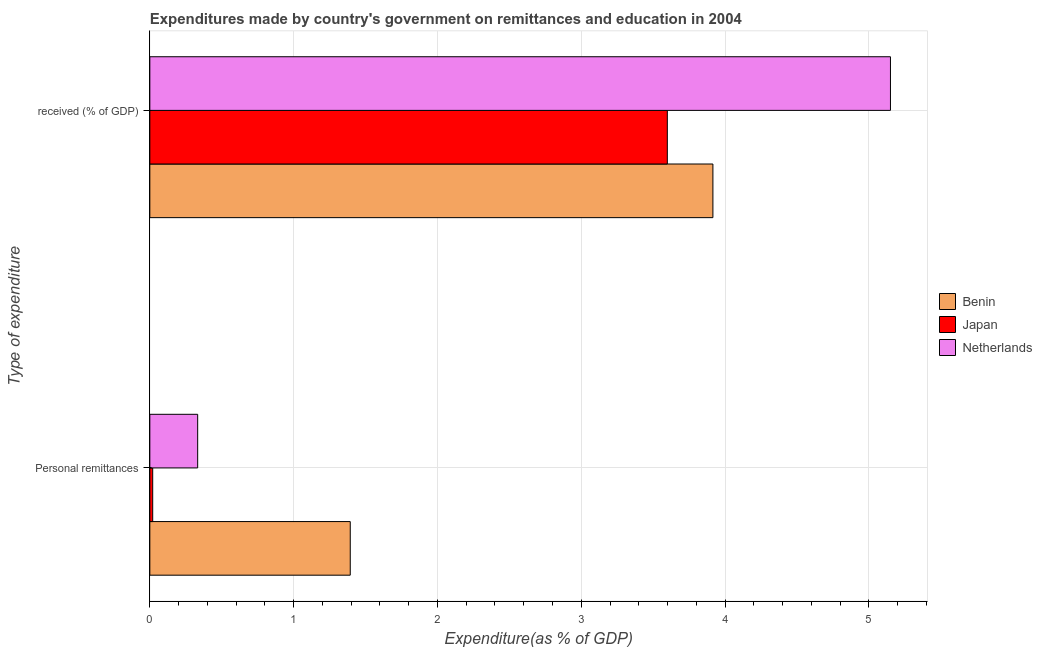How many different coloured bars are there?
Offer a very short reply. 3. How many groups of bars are there?
Provide a short and direct response. 2. Are the number of bars per tick equal to the number of legend labels?
Give a very brief answer. Yes. How many bars are there on the 2nd tick from the bottom?
Ensure brevity in your answer.  3. What is the label of the 1st group of bars from the top?
Provide a short and direct response.  received (% of GDP). What is the expenditure in education in Netherlands?
Offer a terse response. 5.15. Across all countries, what is the maximum expenditure in personal remittances?
Provide a succinct answer. 1.39. Across all countries, what is the minimum expenditure in education?
Offer a terse response. 3.6. In which country was the expenditure in education maximum?
Provide a short and direct response. Netherlands. In which country was the expenditure in personal remittances minimum?
Your answer should be very brief. Japan. What is the total expenditure in personal remittances in the graph?
Offer a terse response. 1.75. What is the difference between the expenditure in personal remittances in Japan and that in Benin?
Make the answer very short. -1.37. What is the difference between the expenditure in education in Netherlands and the expenditure in personal remittances in Japan?
Make the answer very short. 5.13. What is the average expenditure in education per country?
Provide a short and direct response. 4.22. What is the difference between the expenditure in education and expenditure in personal remittances in Netherlands?
Offer a very short reply. 4.82. What is the ratio of the expenditure in education in Japan to that in Benin?
Your answer should be very brief. 0.92. In how many countries, is the expenditure in education greater than the average expenditure in education taken over all countries?
Provide a short and direct response. 1. What does the 3rd bar from the top in  received (% of GDP) represents?
Your answer should be very brief. Benin. What does the 1st bar from the bottom in Personal remittances represents?
Provide a succinct answer. Benin. How many bars are there?
Provide a succinct answer. 6. How many countries are there in the graph?
Provide a succinct answer. 3. Does the graph contain grids?
Your answer should be very brief. Yes. How many legend labels are there?
Provide a succinct answer. 3. How are the legend labels stacked?
Offer a very short reply. Vertical. What is the title of the graph?
Keep it short and to the point. Expenditures made by country's government on remittances and education in 2004. What is the label or title of the X-axis?
Provide a short and direct response. Expenditure(as % of GDP). What is the label or title of the Y-axis?
Provide a short and direct response. Type of expenditure. What is the Expenditure(as % of GDP) of Benin in Personal remittances?
Your answer should be very brief. 1.39. What is the Expenditure(as % of GDP) in Japan in Personal remittances?
Give a very brief answer. 0.02. What is the Expenditure(as % of GDP) of Netherlands in Personal remittances?
Your response must be concise. 0.33. What is the Expenditure(as % of GDP) in Benin in  received (% of GDP)?
Offer a very short reply. 3.92. What is the Expenditure(as % of GDP) in Japan in  received (% of GDP)?
Offer a terse response. 3.6. What is the Expenditure(as % of GDP) of Netherlands in  received (% of GDP)?
Provide a succinct answer. 5.15. Across all Type of expenditure, what is the maximum Expenditure(as % of GDP) of Benin?
Keep it short and to the point. 3.92. Across all Type of expenditure, what is the maximum Expenditure(as % of GDP) of Japan?
Keep it short and to the point. 3.6. Across all Type of expenditure, what is the maximum Expenditure(as % of GDP) of Netherlands?
Offer a very short reply. 5.15. Across all Type of expenditure, what is the minimum Expenditure(as % of GDP) of Benin?
Provide a succinct answer. 1.39. Across all Type of expenditure, what is the minimum Expenditure(as % of GDP) in Japan?
Ensure brevity in your answer.  0.02. Across all Type of expenditure, what is the minimum Expenditure(as % of GDP) in Netherlands?
Your response must be concise. 0.33. What is the total Expenditure(as % of GDP) of Benin in the graph?
Provide a succinct answer. 5.31. What is the total Expenditure(as % of GDP) in Japan in the graph?
Your answer should be very brief. 3.62. What is the total Expenditure(as % of GDP) in Netherlands in the graph?
Give a very brief answer. 5.48. What is the difference between the Expenditure(as % of GDP) of Benin in Personal remittances and that in  received (% of GDP)?
Your response must be concise. -2.52. What is the difference between the Expenditure(as % of GDP) of Japan in Personal remittances and that in  received (% of GDP)?
Ensure brevity in your answer.  -3.58. What is the difference between the Expenditure(as % of GDP) in Netherlands in Personal remittances and that in  received (% of GDP)?
Your response must be concise. -4.82. What is the difference between the Expenditure(as % of GDP) of Benin in Personal remittances and the Expenditure(as % of GDP) of Japan in  received (% of GDP)?
Offer a terse response. -2.2. What is the difference between the Expenditure(as % of GDP) in Benin in Personal remittances and the Expenditure(as % of GDP) in Netherlands in  received (% of GDP)?
Offer a terse response. -3.76. What is the difference between the Expenditure(as % of GDP) in Japan in Personal remittances and the Expenditure(as % of GDP) in Netherlands in  received (% of GDP)?
Your answer should be very brief. -5.13. What is the average Expenditure(as % of GDP) of Benin per Type of expenditure?
Your answer should be compact. 2.65. What is the average Expenditure(as % of GDP) of Japan per Type of expenditure?
Make the answer very short. 1.81. What is the average Expenditure(as % of GDP) of Netherlands per Type of expenditure?
Make the answer very short. 2.74. What is the difference between the Expenditure(as % of GDP) in Benin and Expenditure(as % of GDP) in Japan in Personal remittances?
Your answer should be very brief. 1.37. What is the difference between the Expenditure(as % of GDP) in Benin and Expenditure(as % of GDP) in Netherlands in Personal remittances?
Provide a short and direct response. 1.06. What is the difference between the Expenditure(as % of GDP) in Japan and Expenditure(as % of GDP) in Netherlands in Personal remittances?
Give a very brief answer. -0.31. What is the difference between the Expenditure(as % of GDP) in Benin and Expenditure(as % of GDP) in Japan in  received (% of GDP)?
Provide a succinct answer. 0.32. What is the difference between the Expenditure(as % of GDP) in Benin and Expenditure(as % of GDP) in Netherlands in  received (% of GDP)?
Provide a short and direct response. -1.23. What is the difference between the Expenditure(as % of GDP) of Japan and Expenditure(as % of GDP) of Netherlands in  received (% of GDP)?
Make the answer very short. -1.55. What is the ratio of the Expenditure(as % of GDP) of Benin in Personal remittances to that in  received (% of GDP)?
Your response must be concise. 0.36. What is the ratio of the Expenditure(as % of GDP) of Japan in Personal remittances to that in  received (% of GDP)?
Your response must be concise. 0.01. What is the ratio of the Expenditure(as % of GDP) in Netherlands in Personal remittances to that in  received (% of GDP)?
Keep it short and to the point. 0.06. What is the difference between the highest and the second highest Expenditure(as % of GDP) in Benin?
Your answer should be very brief. 2.52. What is the difference between the highest and the second highest Expenditure(as % of GDP) in Japan?
Offer a very short reply. 3.58. What is the difference between the highest and the second highest Expenditure(as % of GDP) in Netherlands?
Provide a short and direct response. 4.82. What is the difference between the highest and the lowest Expenditure(as % of GDP) of Benin?
Your answer should be compact. 2.52. What is the difference between the highest and the lowest Expenditure(as % of GDP) of Japan?
Offer a very short reply. 3.58. What is the difference between the highest and the lowest Expenditure(as % of GDP) of Netherlands?
Provide a succinct answer. 4.82. 